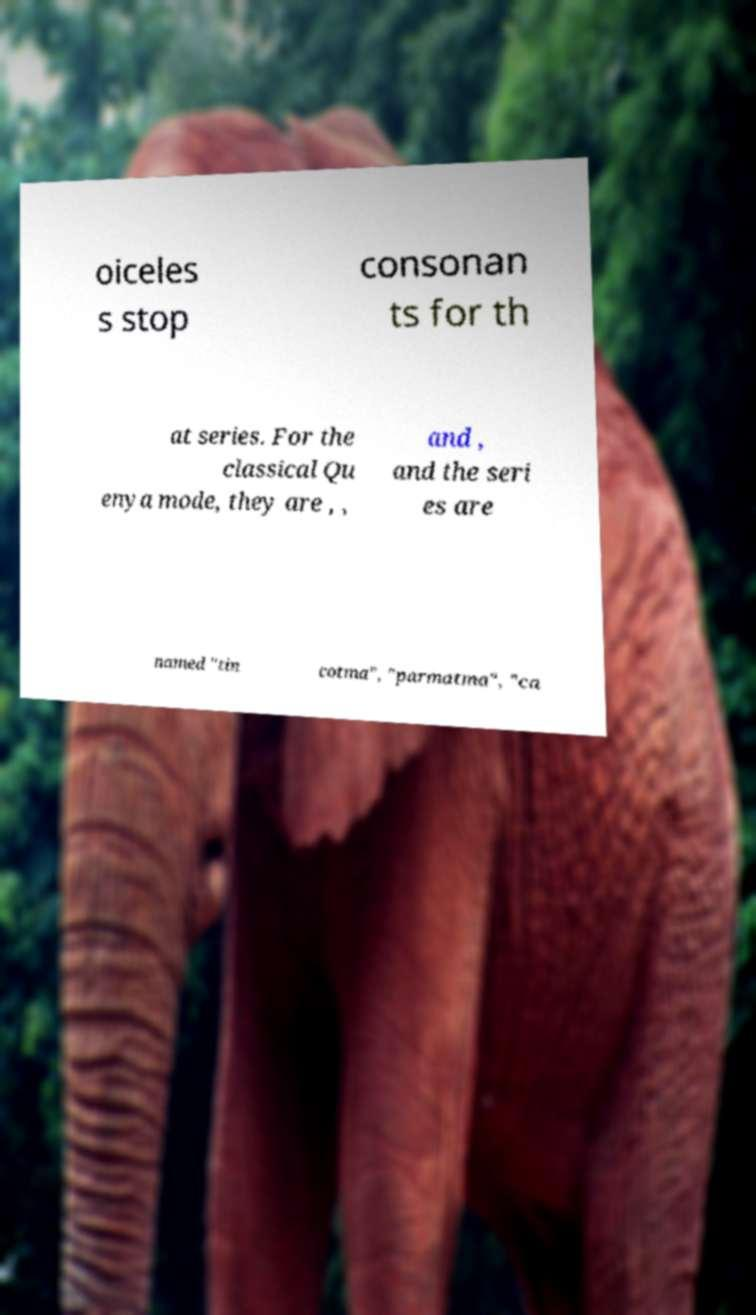Could you assist in decoding the text presented in this image and type it out clearly? oiceles s stop consonan ts for th at series. For the classical Qu enya mode, they are , , and , and the seri es are named "tin cotma", "parmatma", "ca 